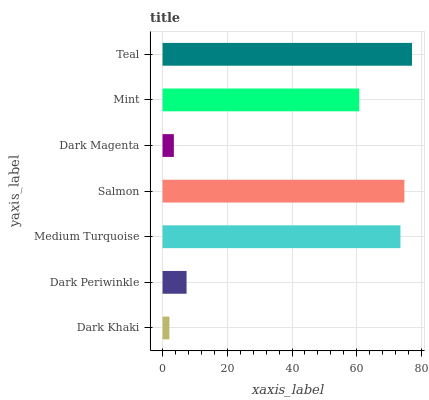Is Dark Khaki the minimum?
Answer yes or no. Yes. Is Teal the maximum?
Answer yes or no. Yes. Is Dark Periwinkle the minimum?
Answer yes or no. No. Is Dark Periwinkle the maximum?
Answer yes or no. No. Is Dark Periwinkle greater than Dark Khaki?
Answer yes or no. Yes. Is Dark Khaki less than Dark Periwinkle?
Answer yes or no. Yes. Is Dark Khaki greater than Dark Periwinkle?
Answer yes or no. No. Is Dark Periwinkle less than Dark Khaki?
Answer yes or no. No. Is Mint the high median?
Answer yes or no. Yes. Is Mint the low median?
Answer yes or no. Yes. Is Medium Turquoise the high median?
Answer yes or no. No. Is Dark Magenta the low median?
Answer yes or no. No. 